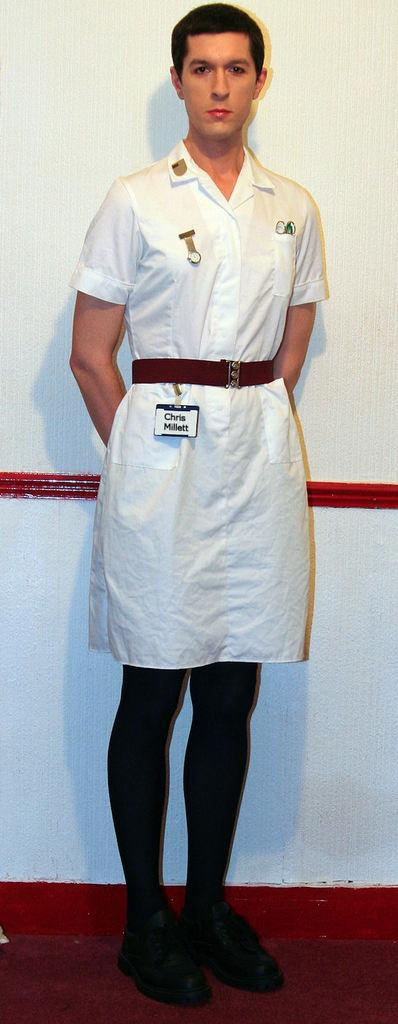<image>
Describe the image concisely. A person in a white uniform and a nametag that says Chris Millett stands for a picture. 